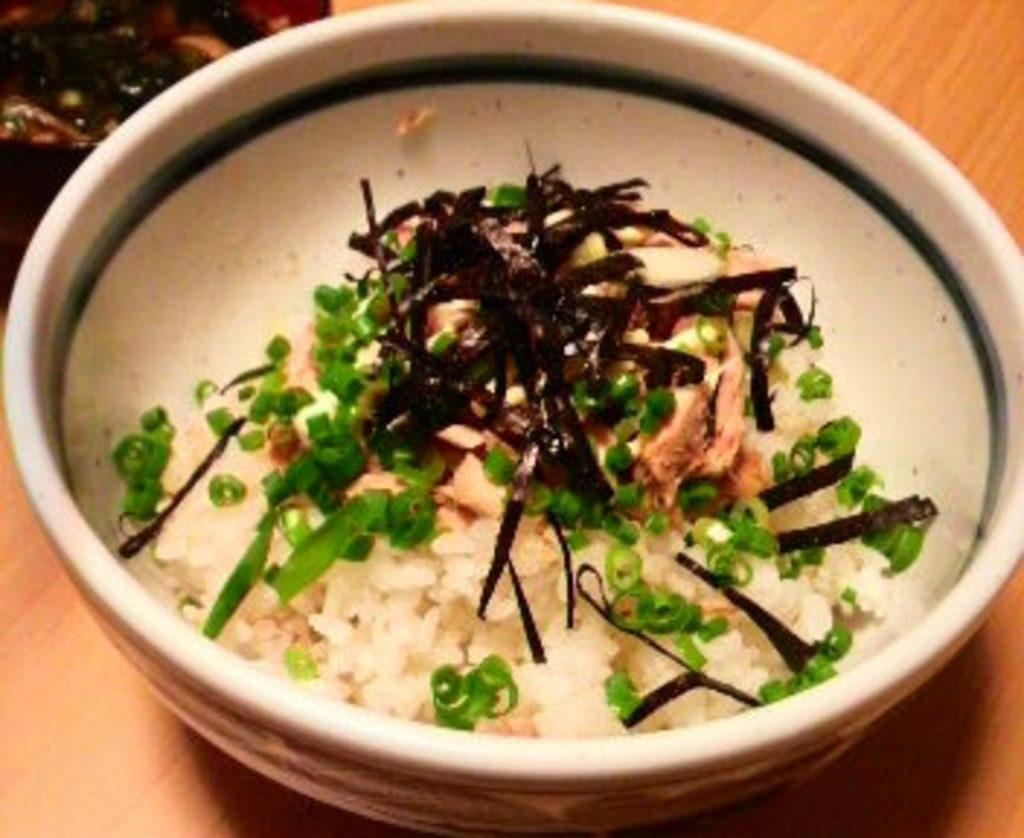Could you give a brief overview of what you see in this image? In this image there is a bowl on the table. In the bowl there is rice on which there is some garnish. 